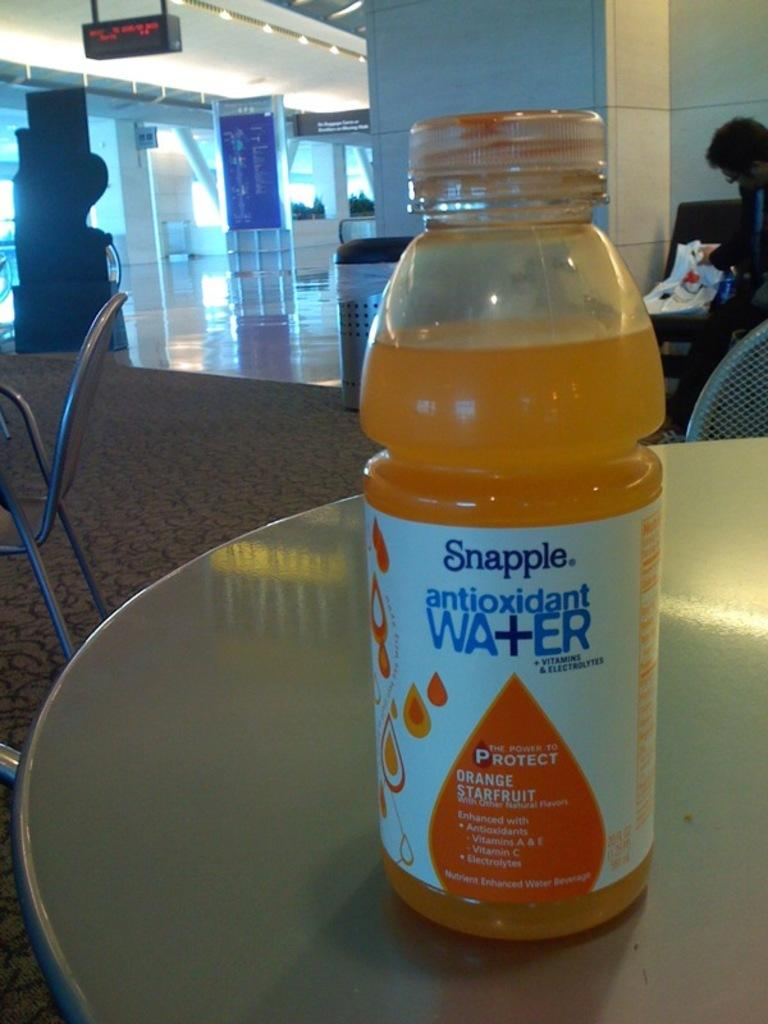<image>
Provide a brief description of the given image. A bottle of orange Snapple that has antioxidants 